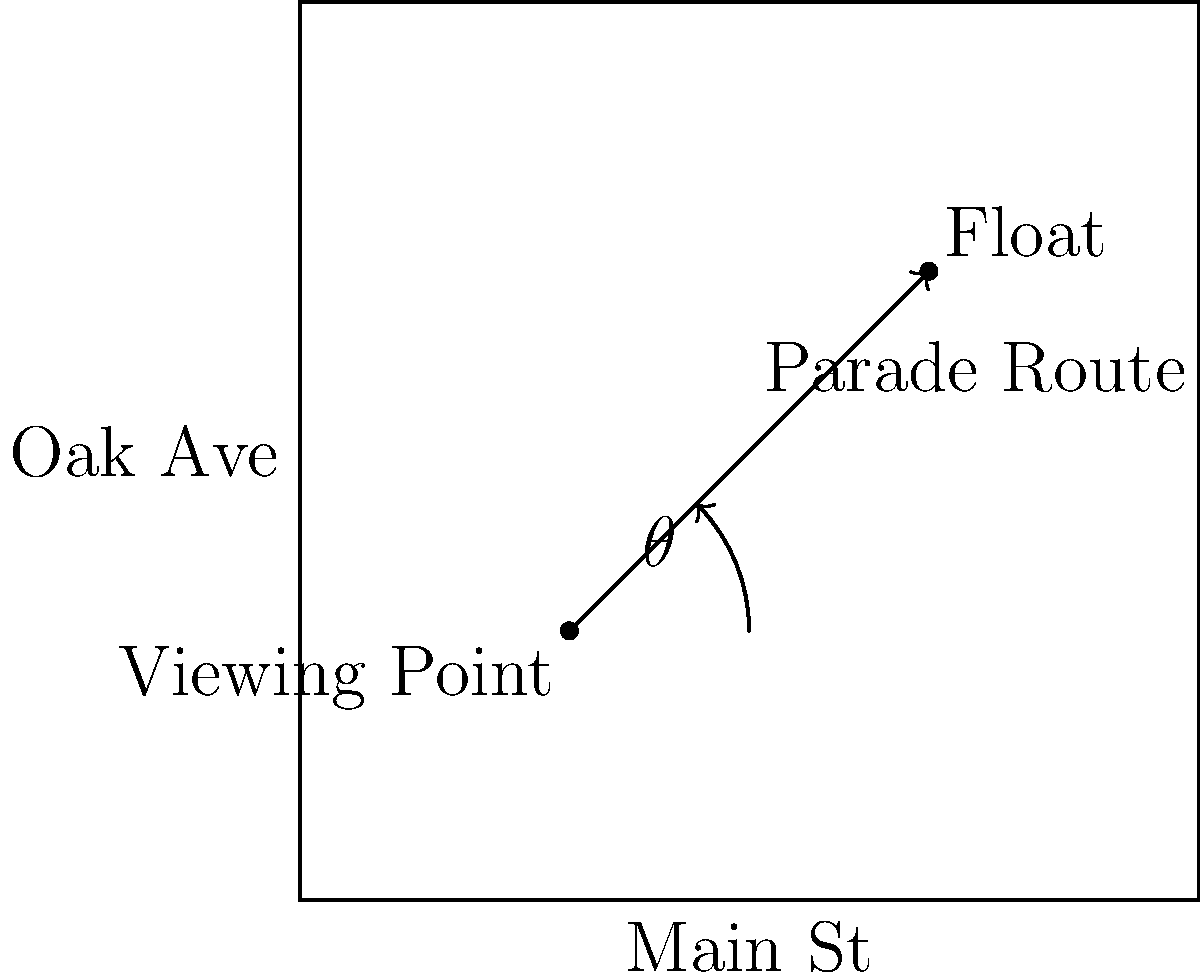Given the street map showing a parade route along the diagonal of a square city block, calculate the viewing angle $\theta$ between the line of sight from a viewing point to a float and the horizontal axis of Main St. The viewing point is located at coordinates (30, 30) and the float is at (70, 70) on a 100x100 unit grid. How can this information be used to optimize float designs and performances for maximum visibility? To calculate the viewing angle $\theta$, we'll use the following steps:

1. Identify the coordinates:
   Viewing point: $(x_1, y_1) = (30, 30)$
   Float position: $(x_2, y_2) = (70, 70)$

2. Calculate the differences in x and y coordinates:
   $\Delta x = x_2 - x_1 = 70 - 30 = 40$
   $\Delta y = y_2 - y_1 = 70 - 30 = 40$

3. Use the arctangent function to calculate the angle:
   $\theta = \arctan(\frac{\Delta y}{\Delta x})$

4. Substitute the values:
   $\theta = \arctan(\frac{40}{40}) = \arctan(1)$

5. Solve:
   $\theta = 45°$

This angle can be used to optimize float designs and performances by:
- Orienting key features of floats at a 45° angle for maximum visibility
- Choreographing performances to face this optimal angle
- Designing costumes and props that are most effective when viewed from this angle
- Planning lighting and special effects to enhance visibility from this perspective
Answer: $45°$ 